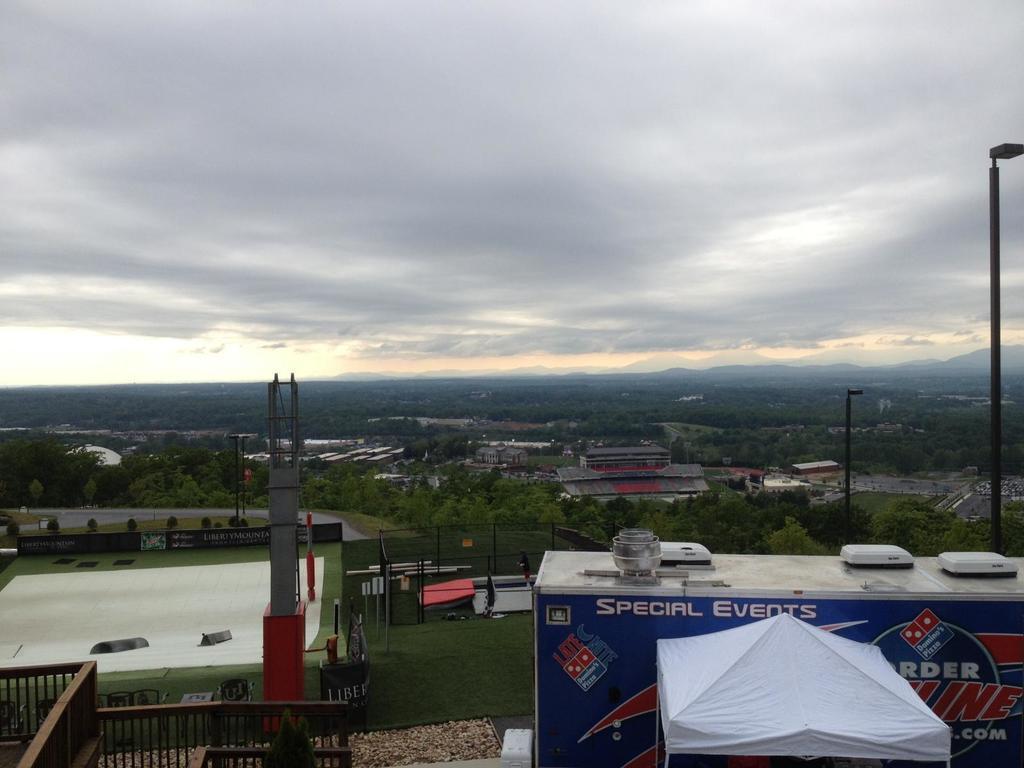Describe this image in one or two sentences. In this image we can see a building. We can also see a pillar, fence, tent and some poles. On the backside we can see some trees, fence, shrubs, buildings, hills and the sky which looks cloudy. 